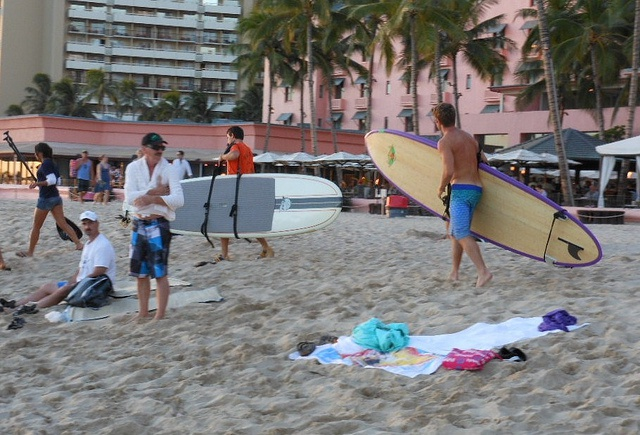Describe the objects in this image and their specific colors. I can see surfboard in gray and tan tones, surfboard in gray, lightgray, and darkgray tones, people in gray, black, and darkgray tones, people in gray, brown, and maroon tones, and people in gray, black, and darkgray tones in this image. 